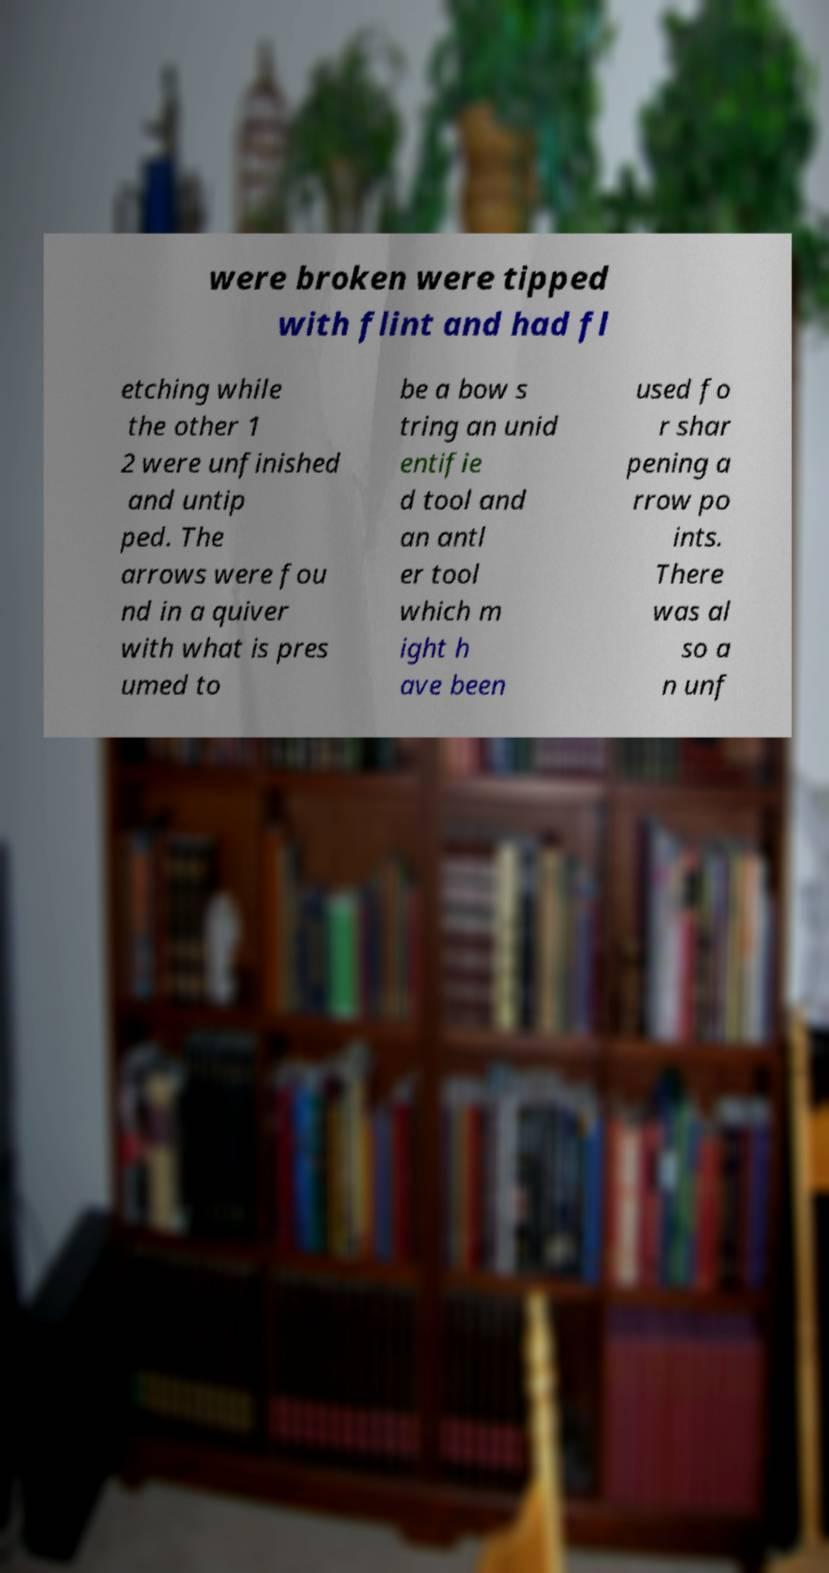For documentation purposes, I need the text within this image transcribed. Could you provide that? were broken were tipped with flint and had fl etching while the other 1 2 were unfinished and untip ped. The arrows were fou nd in a quiver with what is pres umed to be a bow s tring an unid entifie d tool and an antl er tool which m ight h ave been used fo r shar pening a rrow po ints. There was al so a n unf 